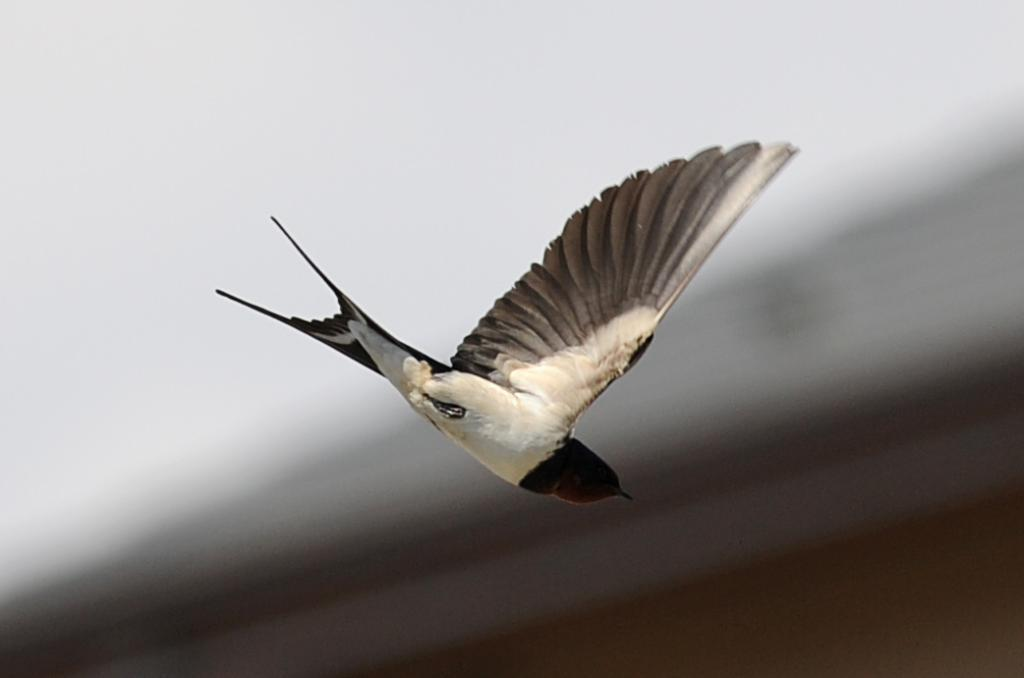What is the main subject of the image? There is a bird in the image. Where is the bird located in the image? The bird is in the center of the image. What is the bird doing in the image? The bird is flying. What rate is the bird's creator charging for the bird in the image? There is no information about a creator or a rate in the image; it simply shows a bird flying. 